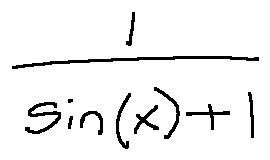Convert formula to latex. <formula><loc_0><loc_0><loc_500><loc_500>\frac { 1 } { \sin ( x ) + 1 }</formula> 